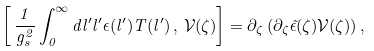<formula> <loc_0><loc_0><loc_500><loc_500>\left [ \, \frac { 1 } { g _ { s } ^ { 2 } } \int ^ { \infty } _ { 0 } d l ^ { \prime } l ^ { \prime } \epsilon ( l ^ { \prime } ) T ( l ^ { \prime } ) \, , \, \mathcal { V } ( \zeta ) \right ] = \partial _ { \zeta } \left ( \partial _ { \zeta } \tilde { \epsilon } ( \zeta ) \mathcal { V } ( \zeta ) \right ) ,</formula> 